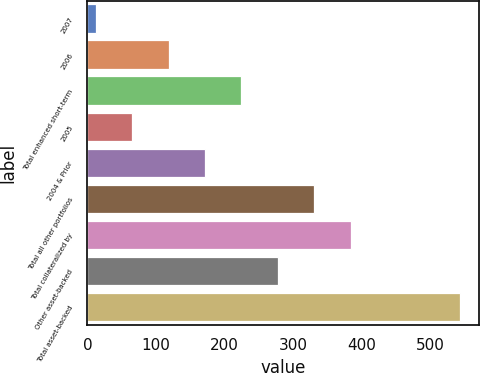Convert chart to OTSL. <chart><loc_0><loc_0><loc_500><loc_500><bar_chart><fcel>2007<fcel>2006<fcel>Total enhanced short-term<fcel>2005<fcel>2004 & Prior<fcel>Total all other portfolios<fcel>Total collateralized by<fcel>Other asset-backed<fcel>Total asset-backed<nl><fcel>12<fcel>118.2<fcel>224.4<fcel>65.1<fcel>171.3<fcel>330.6<fcel>383.7<fcel>277.5<fcel>543<nl></chart> 